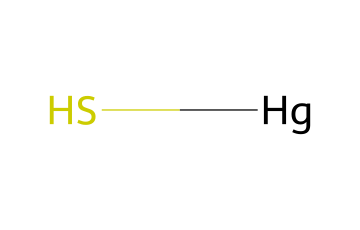What is the chemical formula for cinnabar pigment? The SMILES representation [Hg]S indicates the elements present: mercury (Hg) and sulfur (S). Thus, the chemical formula consists of one mercury atom and one sulfur atom, which leads to the formula HgS.
Answer: HgS How many different types of atoms are present in this chemical? The SMILES notation shows two distinct elements: mercury (Hg) and sulfur (S). Therefore, there are two different types of atoms in this chemical.
Answer: two What type of chemical compound is represented by the structure? The combination of mercury and sulfur in this SMILES notation represents a sulfide, specifically a mercury sulfide, since it consists of only a metal and a non-metal.
Answer: sulfide What is the primary color associated with cinnabar pigment? Cinnabar pigment is known for its bright red color, which is characteristic of the mineral form of mercury sulfide.
Answer: red Why does cinnabar have historical significance in Roman frescoes? Cinnabar was historically valued not only for its vibrant red color, which was used in artwork, but also for its opacity and permanence, making it a favored pigment in Roman frescoes.
Answer: permanence What potential risk does the presence of mercury in this pigment pose? Mercury is toxic and poses health risks upon exposure, whether through inhalation, ingestion, or skin contact, which has implications for the safety of artists and individuals who worked with cinnabar pigment.
Answer: toxicity How many bonds does the chemical likely form based on its structure? In the SMILES representation [Hg]S, mercury (Hg) typically forms a bond with sulfur (S), suggesting a single bond between the two atoms in the compound, indicating a bond count of one.
Answer: one 